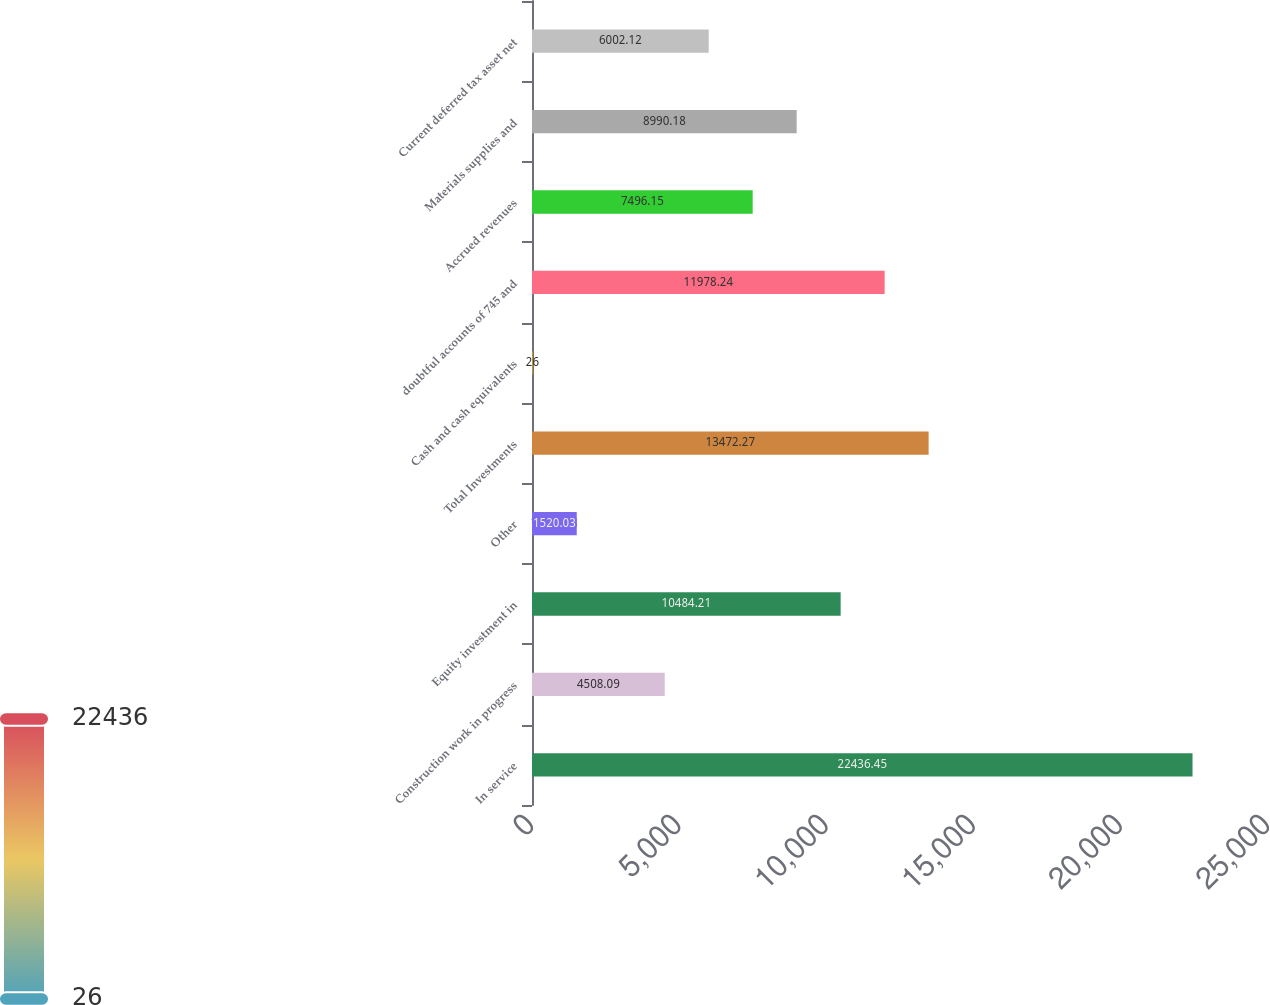<chart> <loc_0><loc_0><loc_500><loc_500><bar_chart><fcel>In service<fcel>Construction work in progress<fcel>Equity investment in<fcel>Other<fcel>Total Investments<fcel>Cash and cash equivalents<fcel>doubtful accounts of 745 and<fcel>Accrued revenues<fcel>Materials supplies and<fcel>Current deferred tax asset net<nl><fcel>22436.5<fcel>4508.09<fcel>10484.2<fcel>1520.03<fcel>13472.3<fcel>26<fcel>11978.2<fcel>7496.15<fcel>8990.18<fcel>6002.12<nl></chart> 